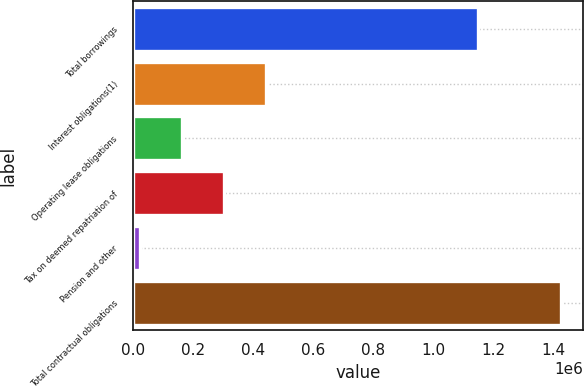<chart> <loc_0><loc_0><loc_500><loc_500><bar_chart><fcel>Total borrowings<fcel>Interest obligations(1)<fcel>Operating lease obligations<fcel>Tax on deemed repatriation of<fcel>Pension and other<fcel>Total contractual obligations<nl><fcel>1.15e+06<fcel>444769<fcel>164137<fcel>304453<fcel>23821<fcel>1.42698e+06<nl></chart> 